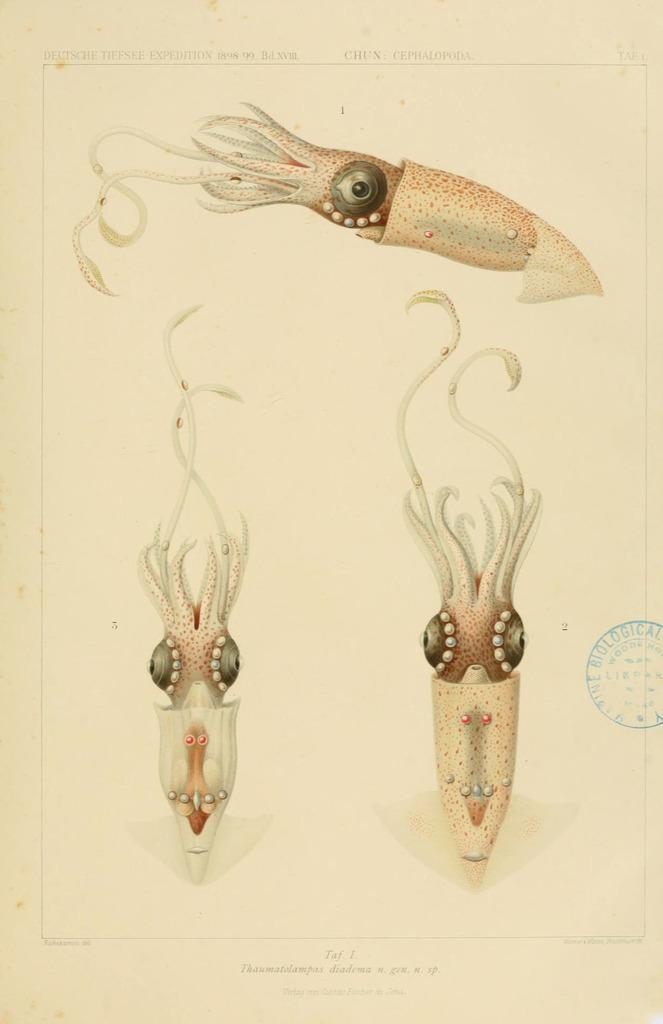What is the medium of the image? The image is on paper. What is the main subject of the image? There is a giant squid in the image. Is there any text accompanying the image? Yes, there is text at the bottom of the image. How many berries are hanging from the tentacles of the giant squid in the image? There are no berries present in the image; it features a giant squid without any berries. What is the chance of finding a key hidden in the image? There is no key present in the image, so the chance of finding one is zero. 